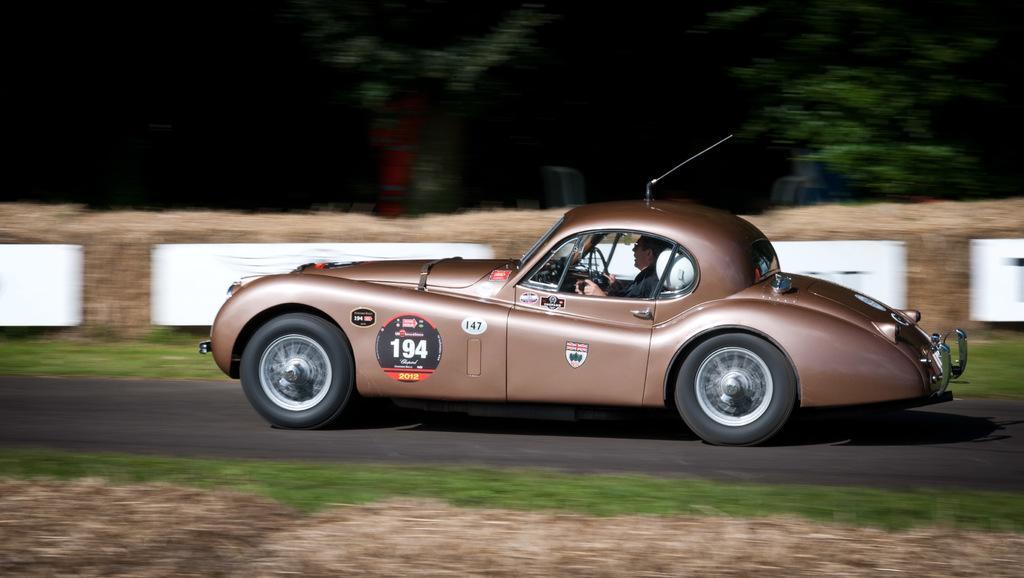How would you summarize this image in a sentence or two? In this image there is a person riding car on the road, beside that there is a grass and trees. 